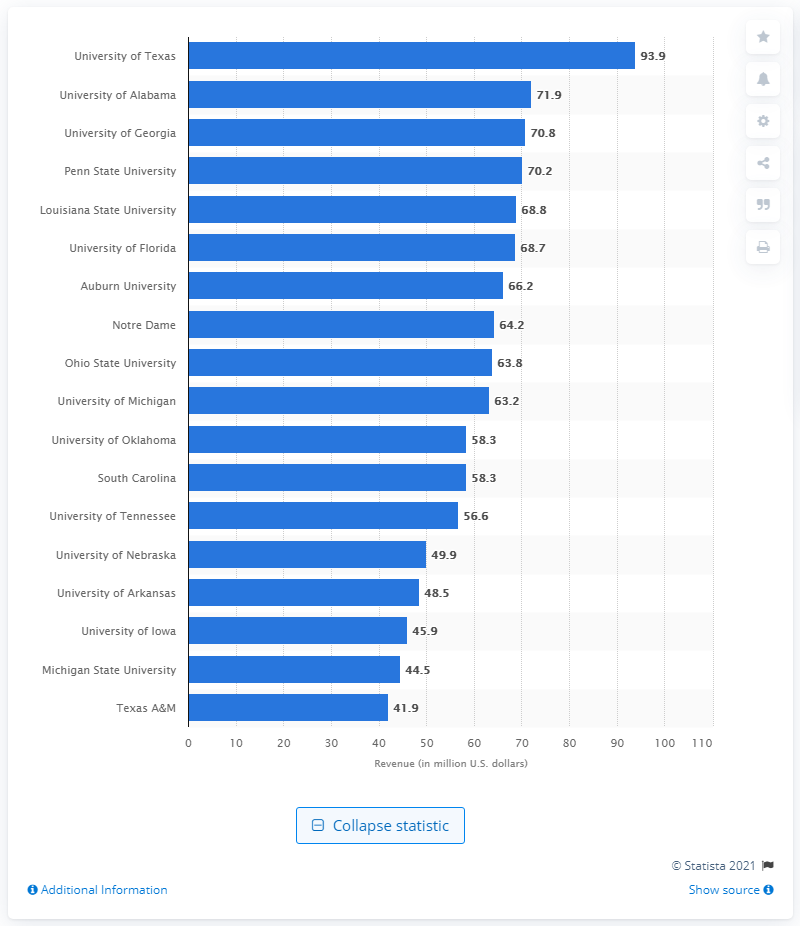Could you identify the source of this data, as indicated in the chart? The source of the data, as indicated in the image, is Statista 2021. 